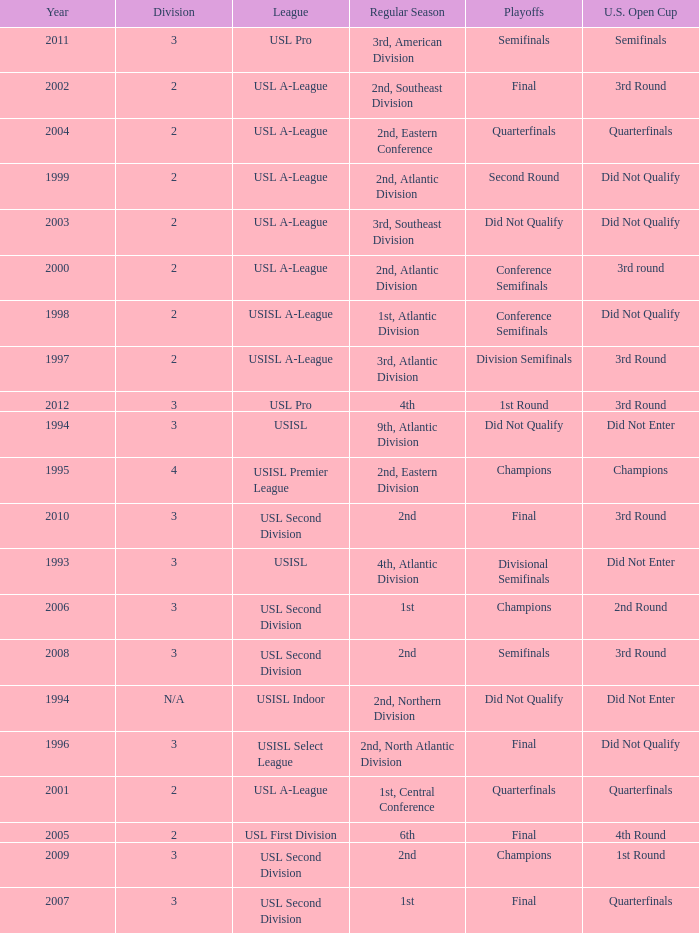How many division  did not qualify for u.s. open cup in 2003 2.0. Could you help me parse every detail presented in this table? {'header': ['Year', 'Division', 'League', 'Regular Season', 'Playoffs', 'U.S. Open Cup'], 'rows': [['2011', '3', 'USL Pro', '3rd, American Division', 'Semifinals', 'Semifinals'], ['2002', '2', 'USL A-League', '2nd, Southeast Division', 'Final', '3rd Round'], ['2004', '2', 'USL A-League', '2nd, Eastern Conference', 'Quarterfinals', 'Quarterfinals'], ['1999', '2', 'USL A-League', '2nd, Atlantic Division', 'Second Round', 'Did Not Qualify'], ['2003', '2', 'USL A-League', '3rd, Southeast Division', 'Did Not Qualify', 'Did Not Qualify'], ['2000', '2', 'USL A-League', '2nd, Atlantic Division', 'Conference Semifinals', '3rd round'], ['1998', '2', 'USISL A-League', '1st, Atlantic Division', 'Conference Semifinals', 'Did Not Qualify'], ['1997', '2', 'USISL A-League', '3rd, Atlantic Division', 'Division Semifinals', '3rd Round'], ['2012', '3', 'USL Pro', '4th', '1st Round', '3rd Round'], ['1994', '3', 'USISL', '9th, Atlantic Division', 'Did Not Qualify', 'Did Not Enter'], ['1995', '4', 'USISL Premier League', '2nd, Eastern Division', 'Champions', 'Champions'], ['2010', '3', 'USL Second Division', '2nd', 'Final', '3rd Round'], ['1993', '3', 'USISL', '4th, Atlantic Division', 'Divisional Semifinals', 'Did Not Enter'], ['2006', '3', 'USL Second Division', '1st', 'Champions', '2nd Round'], ['2008', '3', 'USL Second Division', '2nd', 'Semifinals', '3rd Round'], ['1994', 'N/A', 'USISL Indoor', '2nd, Northern Division', 'Did Not Qualify', 'Did Not Enter'], ['1996', '3', 'USISL Select League', '2nd, North Atlantic Division', 'Final', 'Did Not Qualify'], ['2001', '2', 'USL A-League', '1st, Central Conference', 'Quarterfinals', 'Quarterfinals'], ['2005', '2', 'USL First Division', '6th', 'Final', '4th Round'], ['2009', '3', 'USL Second Division', '2nd', 'Champions', '1st Round'], ['2007', '3', 'USL Second Division', '1st', 'Final', 'Quarterfinals']]} 